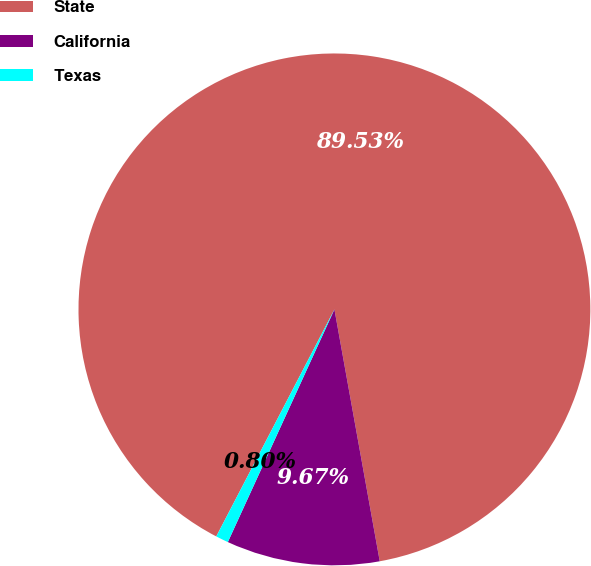<chart> <loc_0><loc_0><loc_500><loc_500><pie_chart><fcel>State<fcel>California<fcel>Texas<nl><fcel>89.53%<fcel>9.67%<fcel>0.8%<nl></chart> 